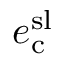Convert formula to latex. <formula><loc_0><loc_0><loc_500><loc_500>e _ { c } ^ { s l }</formula> 